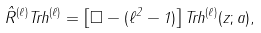<formula> <loc_0><loc_0><loc_500><loc_500>\hat { R } ^ { ( \ell ) } T r h ^ { ( \ell ) } = \left [ \Box - ( \ell ^ { 2 } - 1 ) \right ] T r h ^ { ( \ell ) } ( z ; a ) ,</formula> 